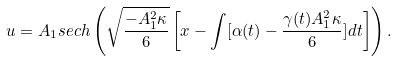<formula> <loc_0><loc_0><loc_500><loc_500>u = A _ { 1 } s e c h \left ( \sqrt { \frac { - A _ { 1 } ^ { 2 } \kappa } { 6 } } \left [ x - \int [ \alpha ( t ) - \frac { \gamma ( t ) A _ { 1 } ^ { 2 } \kappa } { 6 } ] d t \right ] \right ) .</formula> 